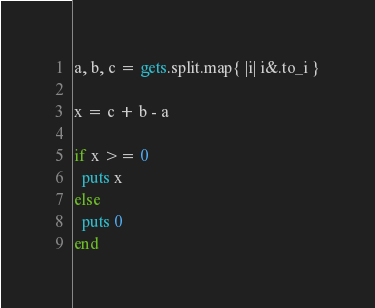<code> <loc_0><loc_0><loc_500><loc_500><_Ruby_>a, b, c = gets.split.map{ |i| i&.to_i }

x = c + b - a

if x >= 0
  puts x
else
  puts 0
end</code> 